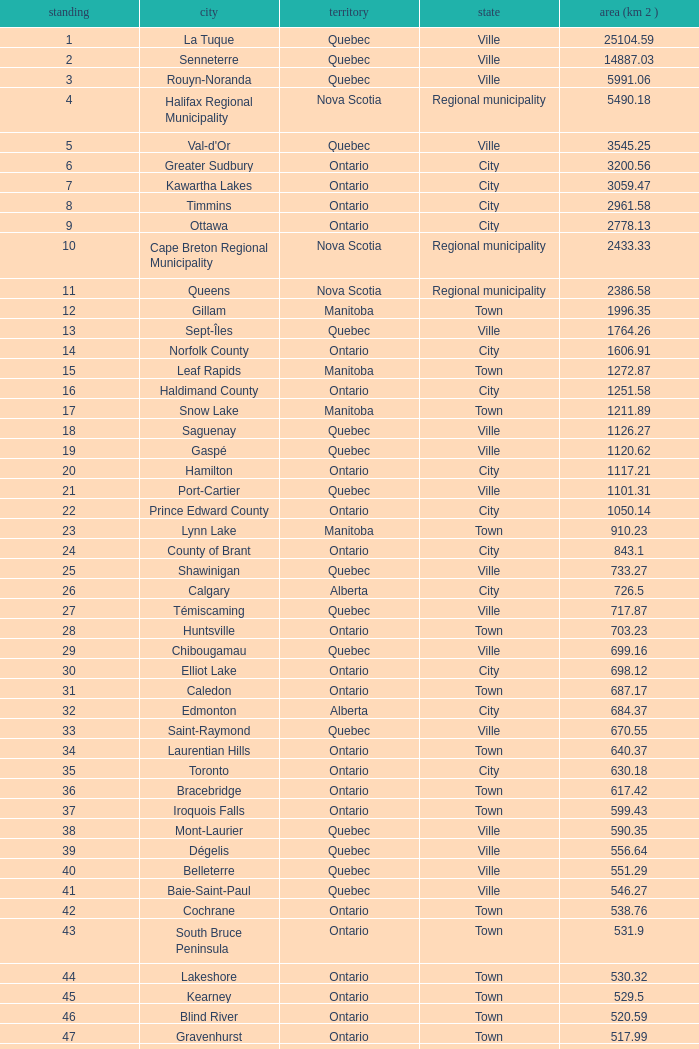What is the listed Status that has the Province of Ontario and Rank of 86? Town. 